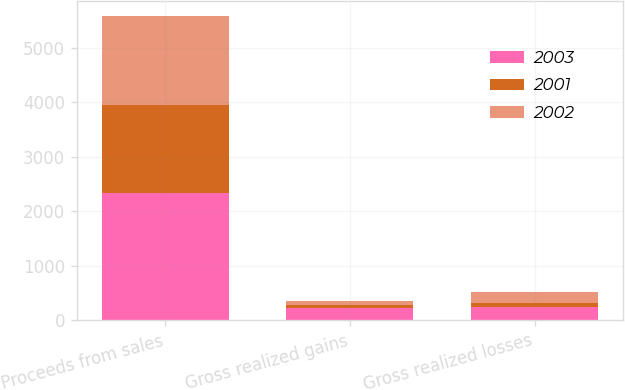Convert chart to OTSL. <chart><loc_0><loc_0><loc_500><loc_500><stacked_bar_chart><ecel><fcel>Proceeds from sales<fcel>Gross realized gains<fcel>Gross realized losses<nl><fcel>2003<fcel>2341<fcel>219<fcel>235<nl><fcel>2001<fcel>1612<fcel>56<fcel>86<nl><fcel>2002<fcel>1624<fcel>76<fcel>189<nl></chart> 